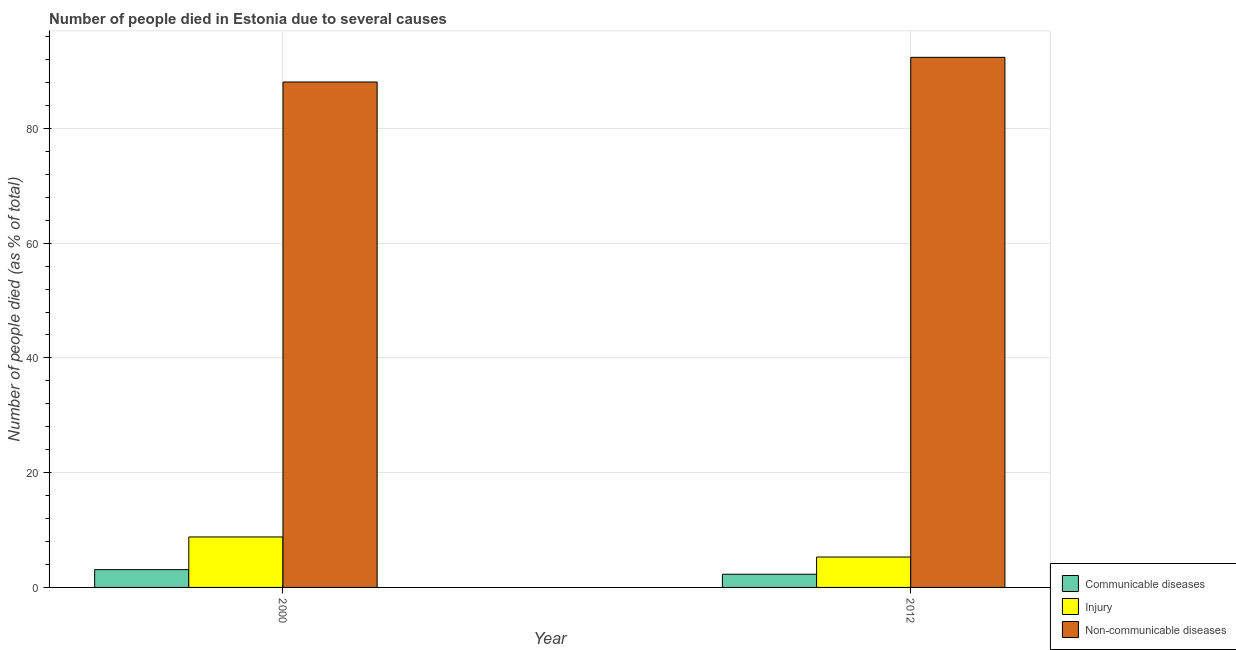How many different coloured bars are there?
Provide a short and direct response. 3. How many groups of bars are there?
Ensure brevity in your answer.  2. Are the number of bars per tick equal to the number of legend labels?
Give a very brief answer. Yes. Are the number of bars on each tick of the X-axis equal?
Provide a short and direct response. Yes. Across all years, what is the maximum number of people who died of communicable diseases?
Offer a very short reply. 3.1. Across all years, what is the minimum number of people who died of injury?
Make the answer very short. 5.3. In which year was the number of people who died of injury minimum?
Offer a terse response. 2012. What is the total number of people who died of injury in the graph?
Ensure brevity in your answer.  14.1. What is the difference between the number of people who died of communicable diseases in 2000 and that in 2012?
Offer a terse response. 0.8. What is the difference between the number of people who dies of non-communicable diseases in 2000 and the number of people who died of injury in 2012?
Your answer should be compact. -4.3. What is the average number of people who dies of non-communicable diseases per year?
Your answer should be very brief. 90.25. What is the ratio of the number of people who died of injury in 2000 to that in 2012?
Give a very brief answer. 1.66. In how many years, is the number of people who died of communicable diseases greater than the average number of people who died of communicable diseases taken over all years?
Provide a short and direct response. 1. What does the 3rd bar from the left in 2000 represents?
Offer a very short reply. Non-communicable diseases. What does the 1st bar from the right in 2000 represents?
Give a very brief answer. Non-communicable diseases. Is it the case that in every year, the sum of the number of people who died of communicable diseases and number of people who died of injury is greater than the number of people who dies of non-communicable diseases?
Provide a short and direct response. No. How many bars are there?
Your answer should be compact. 6. Are all the bars in the graph horizontal?
Your response must be concise. No. How many years are there in the graph?
Your answer should be very brief. 2. Does the graph contain any zero values?
Offer a very short reply. No. How many legend labels are there?
Your answer should be very brief. 3. How are the legend labels stacked?
Keep it short and to the point. Vertical. What is the title of the graph?
Your response must be concise. Number of people died in Estonia due to several causes. Does "Fuel" appear as one of the legend labels in the graph?
Offer a terse response. No. What is the label or title of the X-axis?
Make the answer very short. Year. What is the label or title of the Y-axis?
Provide a succinct answer. Number of people died (as % of total). What is the Number of people died (as % of total) of Communicable diseases in 2000?
Keep it short and to the point. 3.1. What is the Number of people died (as % of total) of Injury in 2000?
Provide a succinct answer. 8.8. What is the Number of people died (as % of total) of Non-communicable diseases in 2000?
Offer a very short reply. 88.1. What is the Number of people died (as % of total) in Communicable diseases in 2012?
Your answer should be compact. 2.3. What is the Number of people died (as % of total) in Injury in 2012?
Offer a terse response. 5.3. What is the Number of people died (as % of total) in Non-communicable diseases in 2012?
Make the answer very short. 92.4. Across all years, what is the maximum Number of people died (as % of total) of Communicable diseases?
Provide a succinct answer. 3.1. Across all years, what is the maximum Number of people died (as % of total) in Non-communicable diseases?
Offer a very short reply. 92.4. Across all years, what is the minimum Number of people died (as % of total) in Non-communicable diseases?
Provide a succinct answer. 88.1. What is the total Number of people died (as % of total) of Non-communicable diseases in the graph?
Make the answer very short. 180.5. What is the difference between the Number of people died (as % of total) in Injury in 2000 and that in 2012?
Your answer should be very brief. 3.5. What is the difference between the Number of people died (as % of total) of Non-communicable diseases in 2000 and that in 2012?
Your answer should be compact. -4.3. What is the difference between the Number of people died (as % of total) of Communicable diseases in 2000 and the Number of people died (as % of total) of Non-communicable diseases in 2012?
Your answer should be compact. -89.3. What is the difference between the Number of people died (as % of total) of Injury in 2000 and the Number of people died (as % of total) of Non-communicable diseases in 2012?
Your response must be concise. -83.6. What is the average Number of people died (as % of total) of Communicable diseases per year?
Provide a short and direct response. 2.7. What is the average Number of people died (as % of total) of Injury per year?
Provide a succinct answer. 7.05. What is the average Number of people died (as % of total) in Non-communicable diseases per year?
Provide a short and direct response. 90.25. In the year 2000, what is the difference between the Number of people died (as % of total) in Communicable diseases and Number of people died (as % of total) in Injury?
Provide a short and direct response. -5.7. In the year 2000, what is the difference between the Number of people died (as % of total) of Communicable diseases and Number of people died (as % of total) of Non-communicable diseases?
Your response must be concise. -85. In the year 2000, what is the difference between the Number of people died (as % of total) in Injury and Number of people died (as % of total) in Non-communicable diseases?
Your response must be concise. -79.3. In the year 2012, what is the difference between the Number of people died (as % of total) of Communicable diseases and Number of people died (as % of total) of Injury?
Keep it short and to the point. -3. In the year 2012, what is the difference between the Number of people died (as % of total) in Communicable diseases and Number of people died (as % of total) in Non-communicable diseases?
Ensure brevity in your answer.  -90.1. In the year 2012, what is the difference between the Number of people died (as % of total) of Injury and Number of people died (as % of total) of Non-communicable diseases?
Ensure brevity in your answer.  -87.1. What is the ratio of the Number of people died (as % of total) of Communicable diseases in 2000 to that in 2012?
Ensure brevity in your answer.  1.35. What is the ratio of the Number of people died (as % of total) in Injury in 2000 to that in 2012?
Offer a terse response. 1.66. What is the ratio of the Number of people died (as % of total) of Non-communicable diseases in 2000 to that in 2012?
Ensure brevity in your answer.  0.95. What is the difference between the highest and the second highest Number of people died (as % of total) of Injury?
Make the answer very short. 3.5. What is the difference between the highest and the lowest Number of people died (as % of total) of Communicable diseases?
Your answer should be very brief. 0.8. What is the difference between the highest and the lowest Number of people died (as % of total) in Non-communicable diseases?
Offer a terse response. 4.3. 